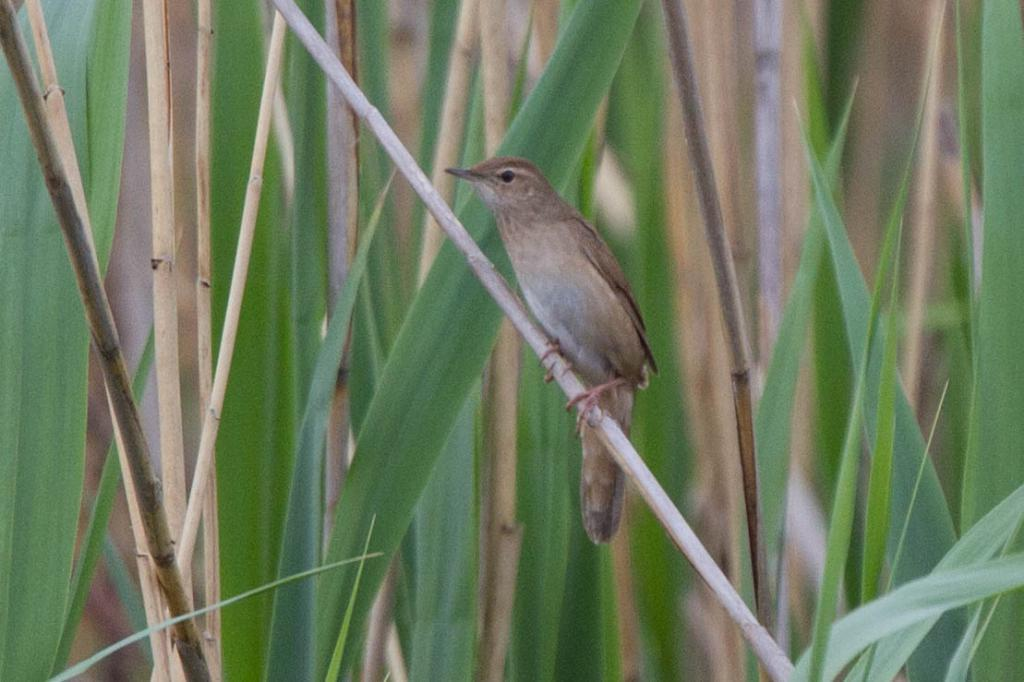What is the main subject in the front of the image? There is a bird in the front of the image. What can be seen in the background of the image? There are leaves visible in the background of the image. What type of sweater is the bird wearing on stage in the image? There is no bird wearing a sweater on stage in the image; the bird is not on a stage, and there is no mention of a sweater. 